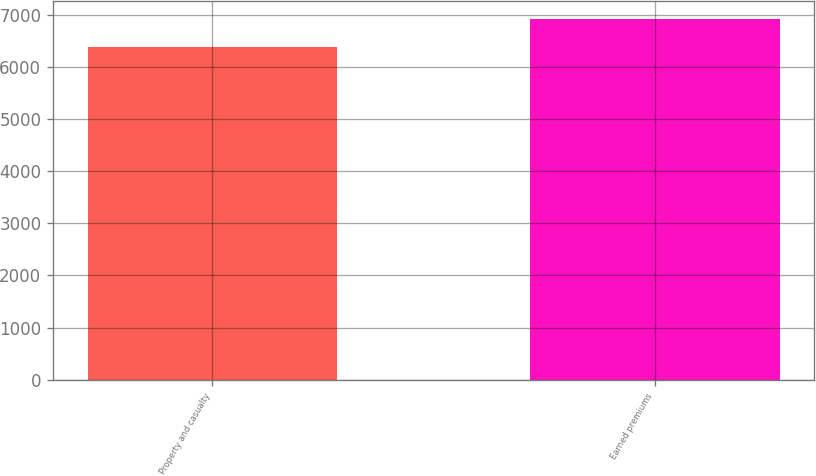Convert chart to OTSL. <chart><loc_0><loc_0><loc_500><loc_500><bar_chart><fcel>Property and casualty<fcel>Earned premiums<nl><fcel>6373<fcel>6921<nl></chart> 